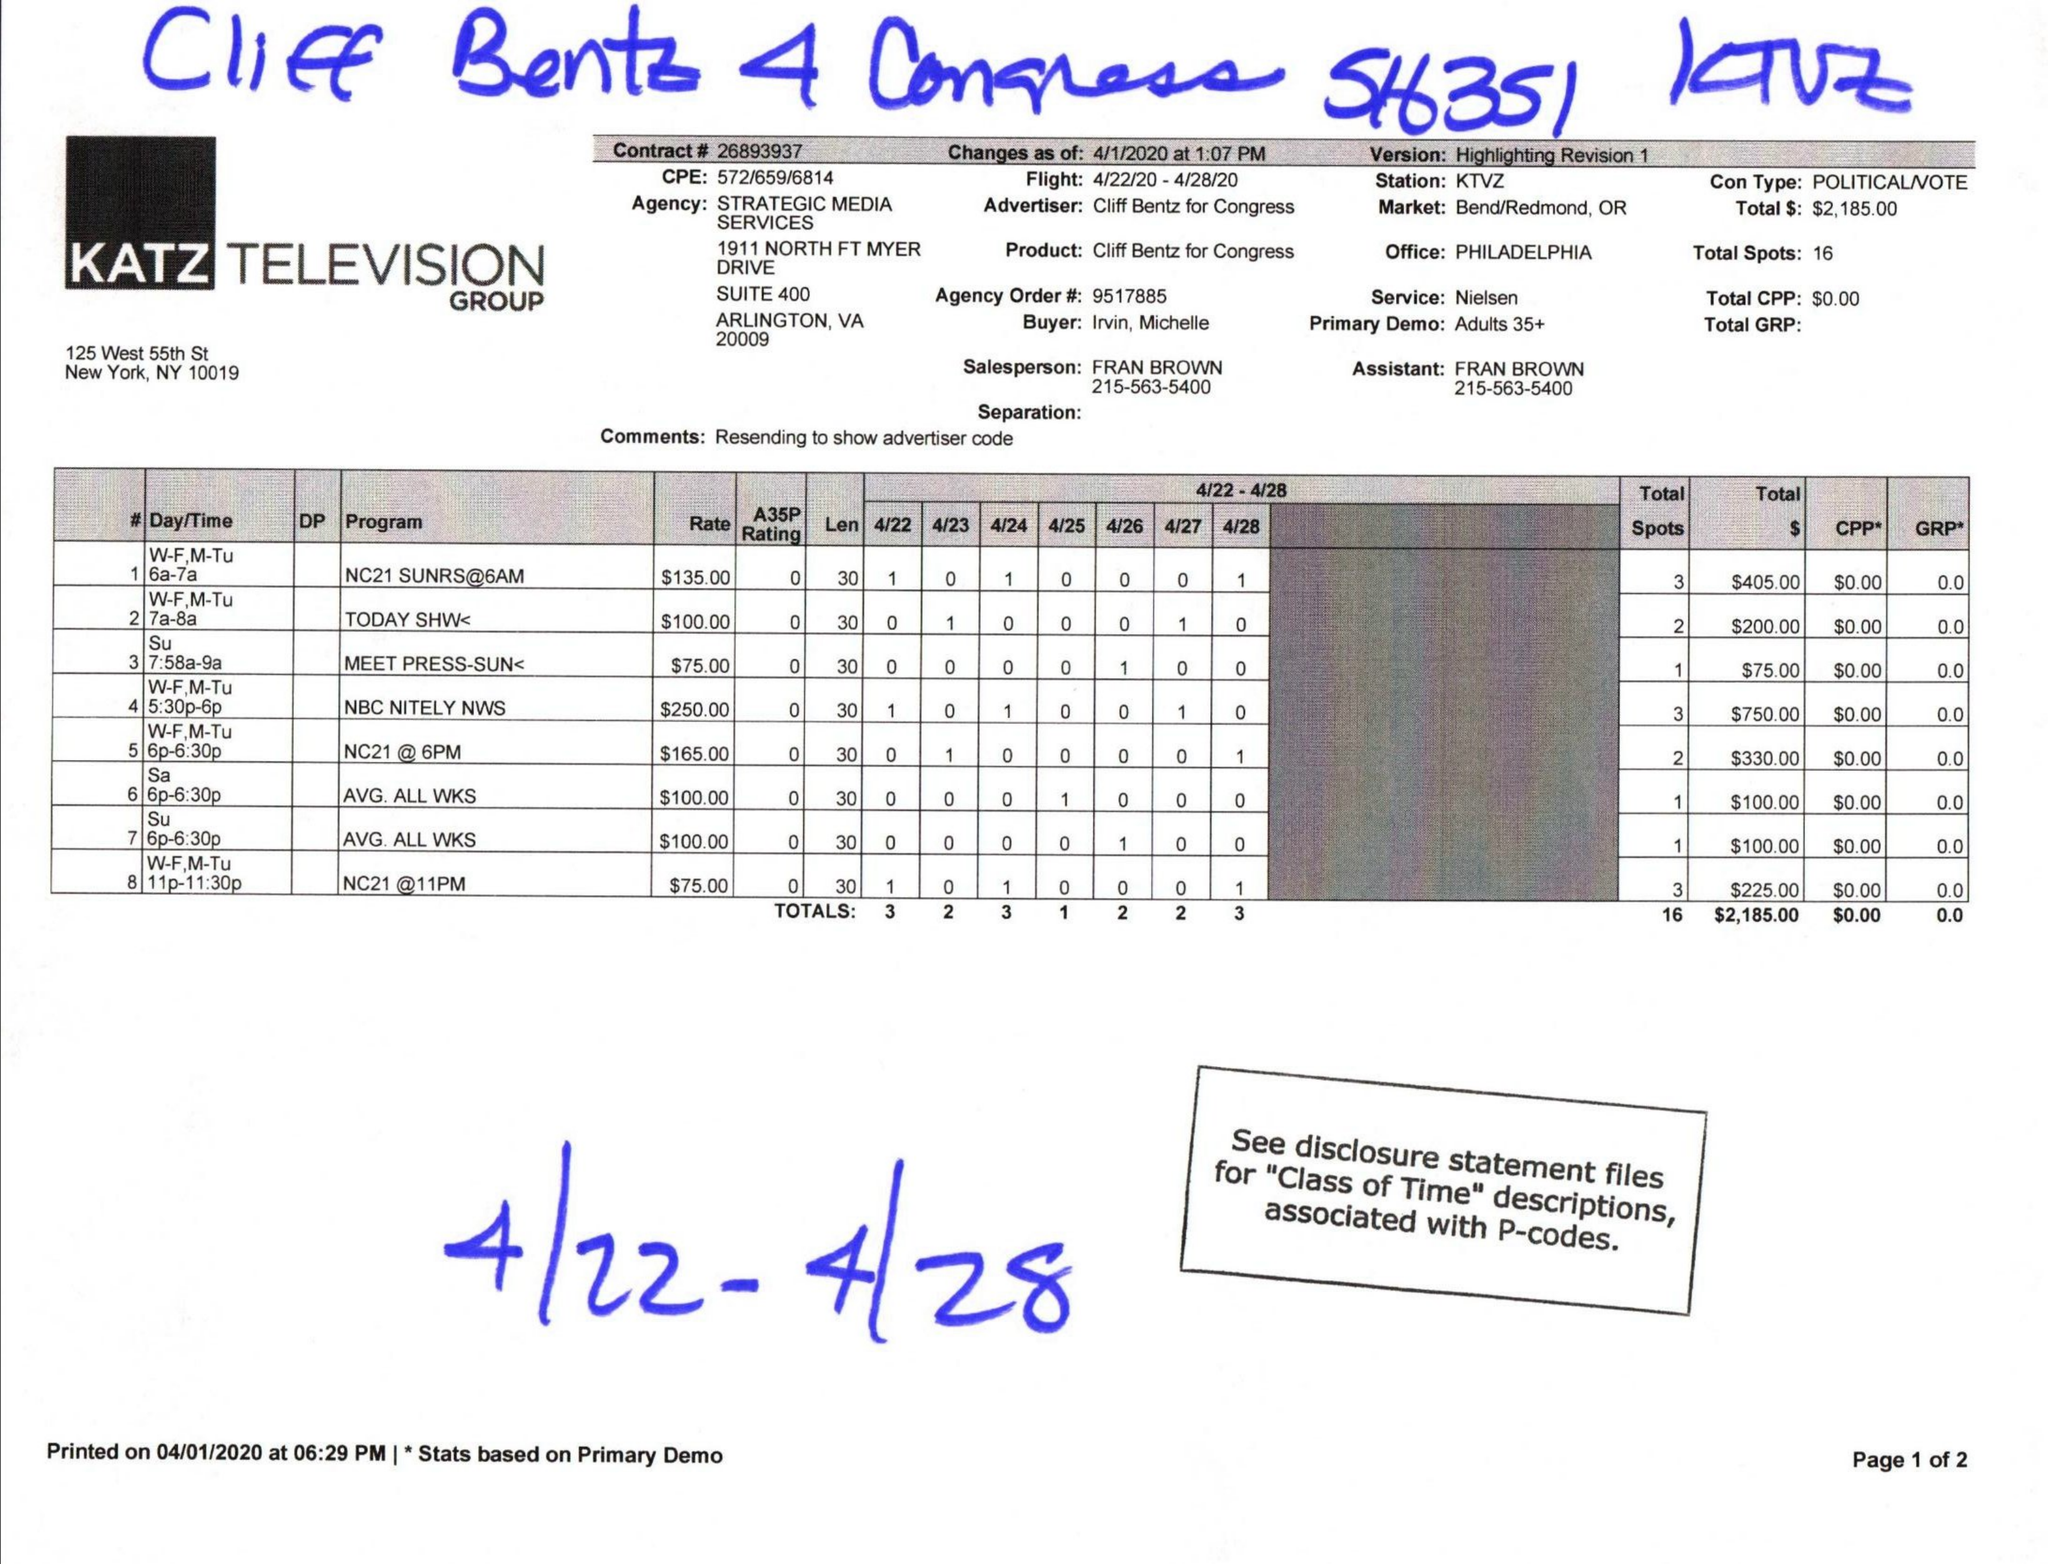What is the value for the advertiser?
Answer the question using a single word or phrase. CLIFF BENTZ FOR CONGRESS 